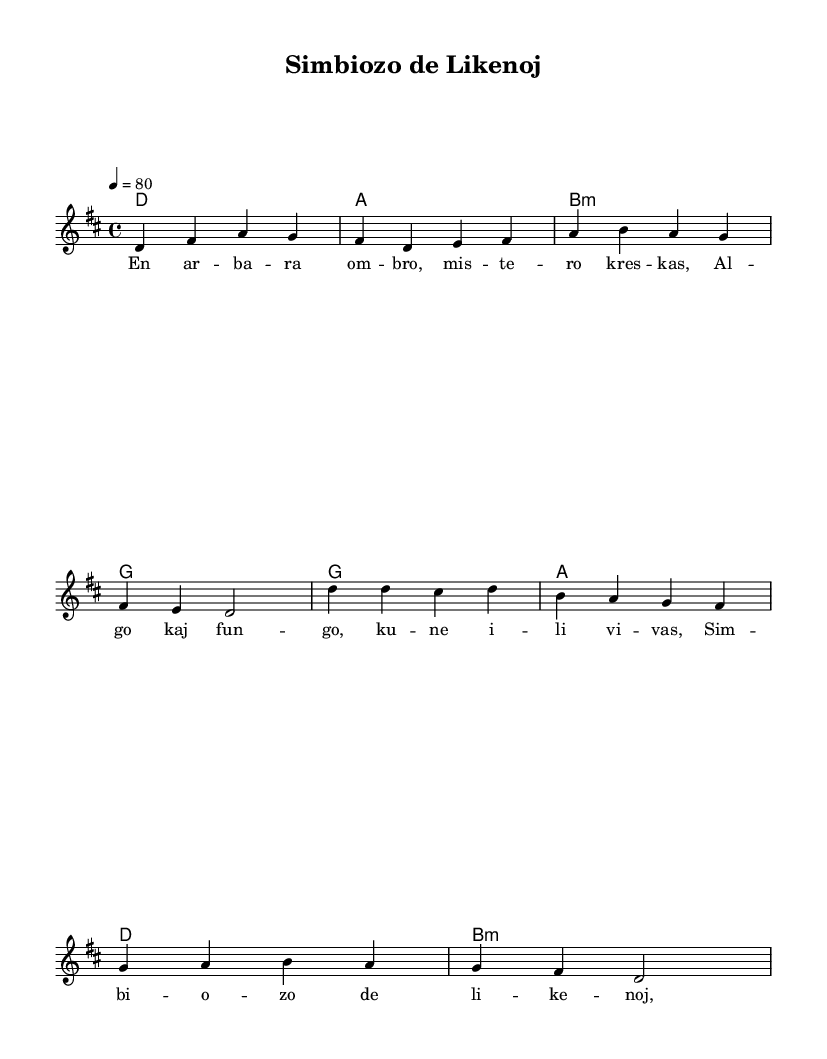What is the key signature of this music? The key signature is indicated at the beginning of the score and shows that the music is in D major, which has two sharps (F# and C#).
Answer: D major What is the time signature of this music? The time signature appears at the beginning of the score and indicates that there are four beats in each measure, making it a 4/4 time signature.
Answer: 4/4 What is the tempo marking given for this piece? The tempo marking "4 = 80" suggests that there are 80 beats per minute, indicating a moderate pace for performing the piece.
Answer: 80 How many verses are in this folk-rock ballad? The sheet music lists the lyric lines for the verse, which indicates a single verse followed by a chorus. Thus, there is one complete verse before repeating the chorus.
Answer: 1 What chord follows the first measure of the verse? The chord shown above the first measure of melody indicates a D major chord, which follows the format of folk-rock ballads where the verse structure typically begins with the tonic.
Answer: D What type of rhyme scheme is used in the verse lyrics? The verse lyrics present a loose structure with the ending words creating a pattern that resembles a couplet style, where alternate lines rhyme.
Answer: Couplets What is the main theme of this ballad? The lyrics focus on the symbiotic relationship and interactions between lichens and their environment, showcasing a naturalistic theme.
Answer: Symbiosis 